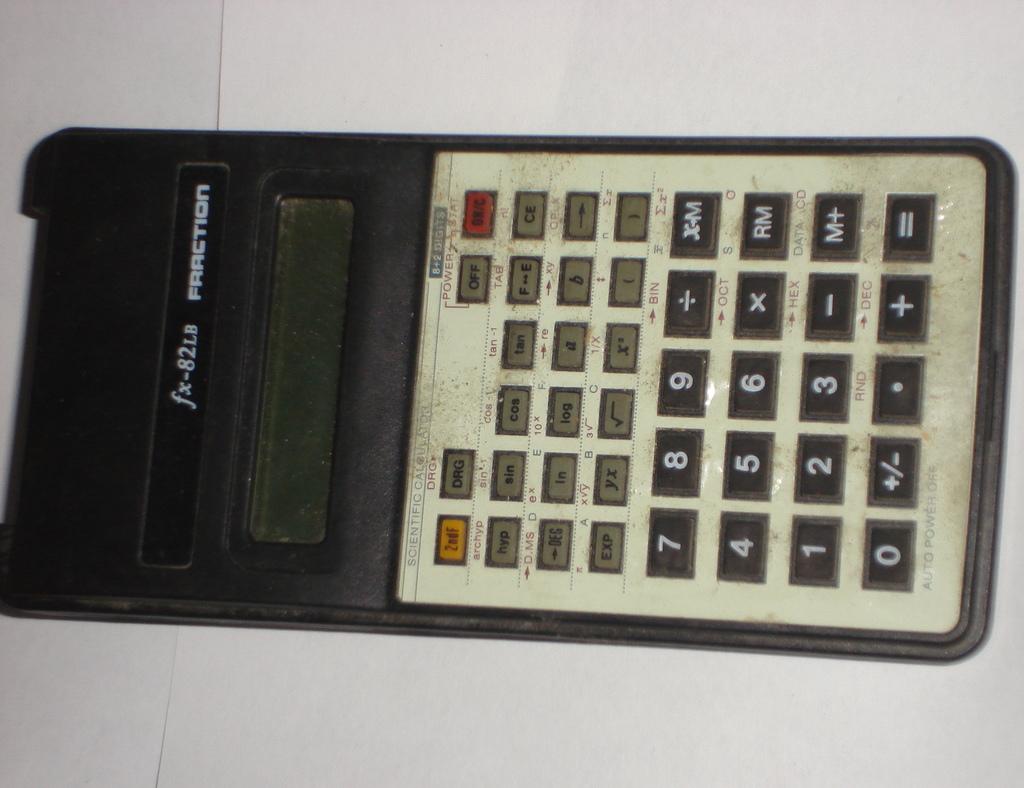What calculator brand?
Make the answer very short. Fraction. Is fraction a quality maker of calculator's?
Give a very brief answer. Yes. 